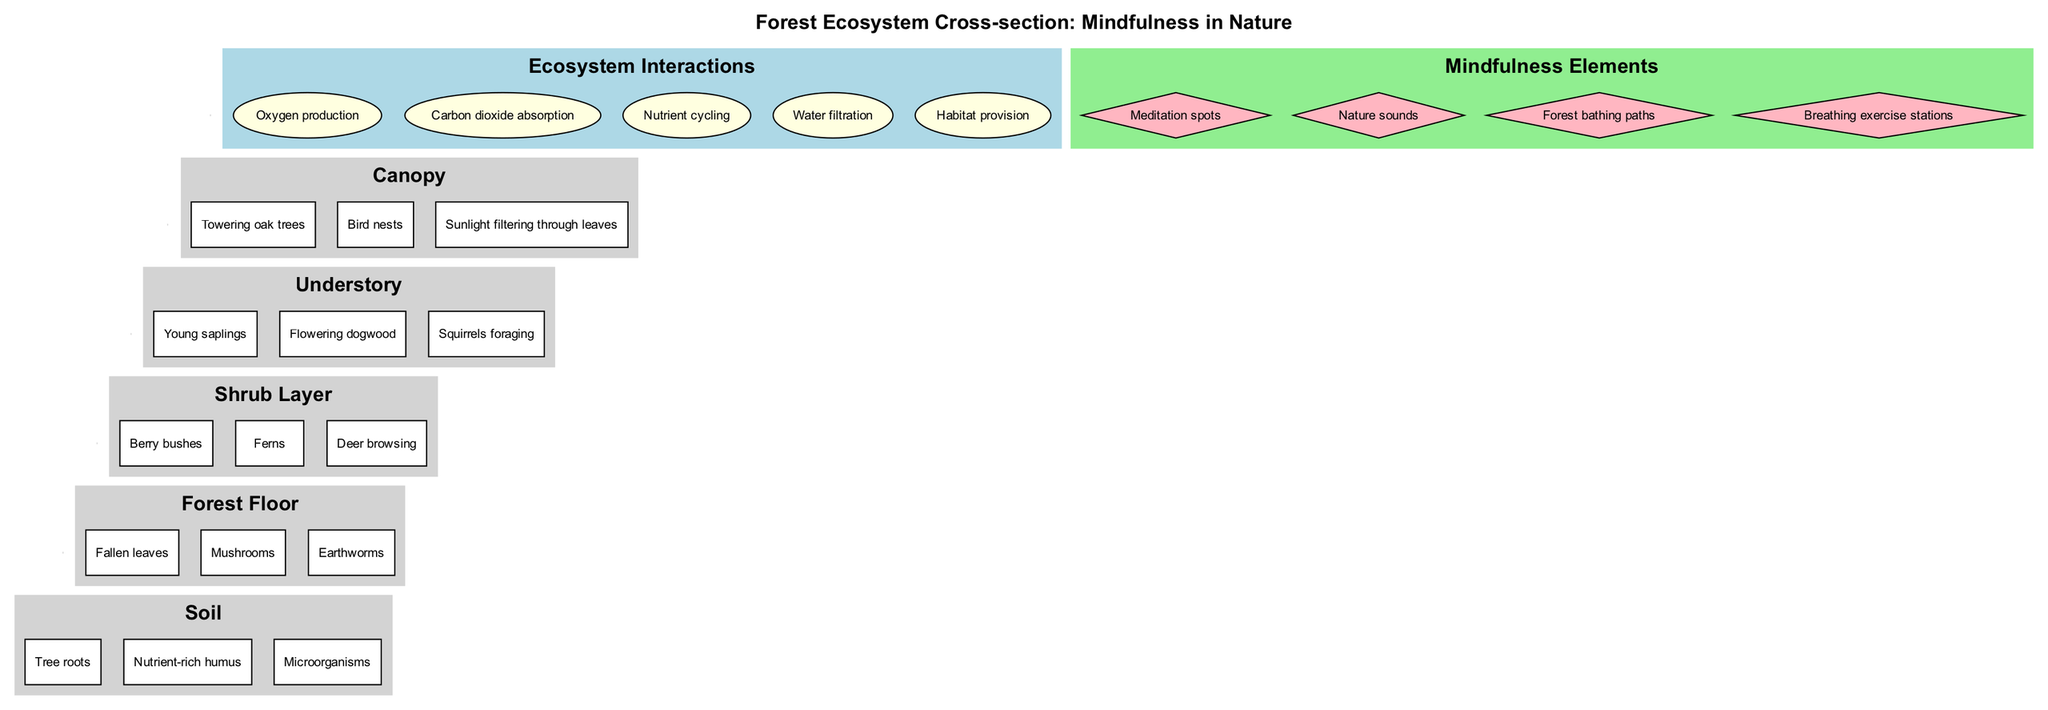What is the top layer of the forest ecosystem? The diagram includes a clear hierarchical arrangement, with the topmost layer listed as the Canopy.
Answer: Canopy How many elements are in the Shrub Layer? By examining the elements specified for the Shrub Layer, we see it contains three components: Berry bushes, Ferns, and Deer browsing.
Answer: 3 Which layer contains Earthworms? The diagram specifies that Earthworms are listed as an element in the Forest Floor layer, which is positioned below the Shrub Layer.
Answer: Forest Floor What is one of the interactions related to water in the ecosystem? The interactions display water-related functions, and "Water filtration" is identified as one of those interactions within the ecosystem.
Answer: Water filtration What color represents the mindfulness elements in the diagram? The subgraph for mindfulness elements highlights the color light green, which is evident from the color coding provided for that section.
Answer: Light green Which layer has young saplings as an element? Scanning through the layers, "Young saplings" appear in the Understory layer, identifying it as the appropriate answer here.
Answer: Understory How many mindfulness elements are represented in the diagram? The diagram details four mindfulness elements distinctly shown under their specific subgraph, allowing for a straightforward count.
Answer: 4 What is one role of the microorganisms in the soil? The soil contains microorganisms which are part of the nutrient cycling process, emphasizing their ecological function as indicated in the interactions.
Answer: Nutrient cycling Name an animal mentioned in the Understory layer. Upon reviewing the Understory section, "Squirrels foraging" is clearly noted, making it the identifiable animal in this layer.
Answer: Squirrels foraging 